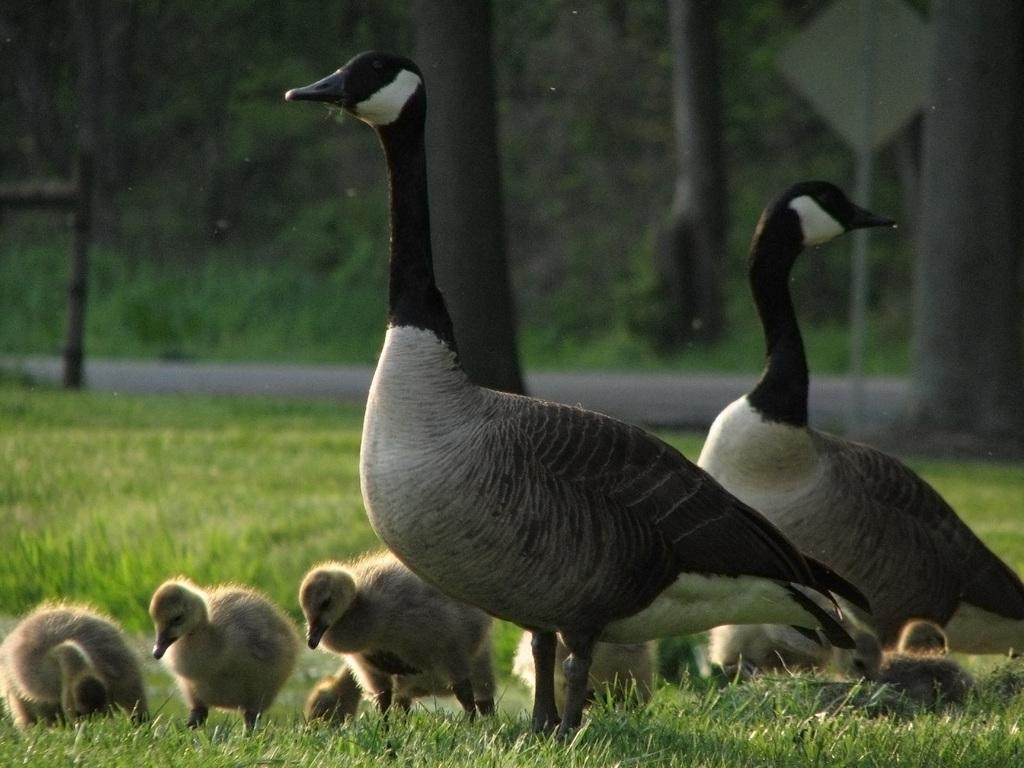How many geese are in the image? There are two geese in the image. What are the geese standing on? The geese are standing on the grass. Are there any baby geese in the image? Yes, there are baby geese in the image. What can be seen in the background of the image? In the background of the image, there is a sign board, a road, trees, and plants. What type of silver material is used to create the boundary in the image? There is no silver material or boundary present in the image. What type of cast can be seen on the geese in the image? There are no casts visible on the geese in the image. 